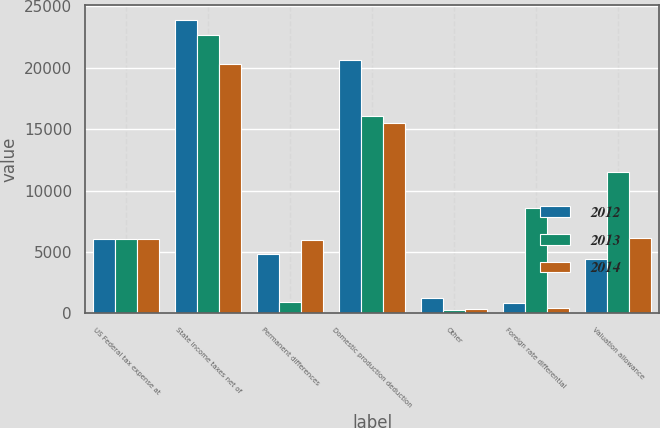Convert chart to OTSL. <chart><loc_0><loc_0><loc_500><loc_500><stacked_bar_chart><ecel><fcel>US Federal tax expense at<fcel>State income taxes net of<fcel>Permanent differences<fcel>Domestic production deduction<fcel>Other<fcel>Foreign rate differential<fcel>Valuation allowance<nl><fcel>2012<fcel>6055<fcel>23859<fcel>4816<fcel>20607<fcel>1267<fcel>817<fcel>4406<nl><fcel>2013<fcel>6055<fcel>22640<fcel>936<fcel>16039<fcel>266<fcel>8566<fcel>11501<nl><fcel>2014<fcel>6055<fcel>20252<fcel>5968<fcel>15469<fcel>388<fcel>425<fcel>6142<nl></chart> 